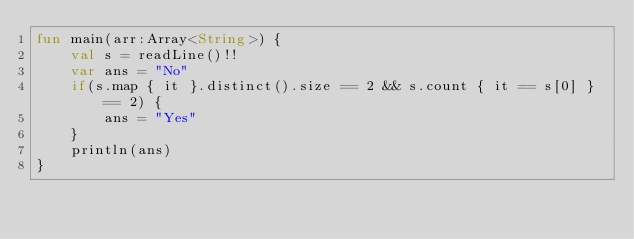Convert code to text. <code><loc_0><loc_0><loc_500><loc_500><_Kotlin_>fun main(arr:Array<String>) {
    val s = readLine()!!
    var ans = "No"
    if(s.map { it }.distinct().size == 2 && s.count { it == s[0] } == 2) {
        ans = "Yes"
    }
    println(ans)
}
</code> 